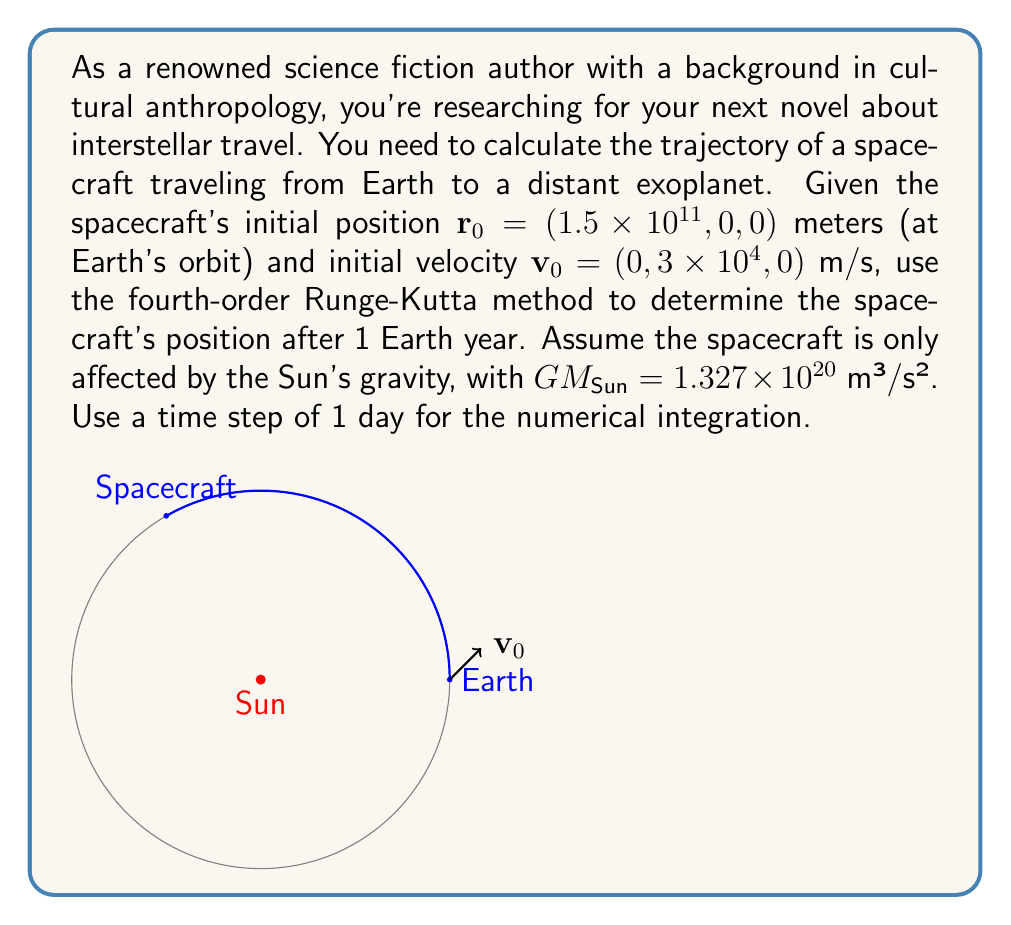What is the answer to this math problem? To solve this problem, we'll use the fourth-order Runge-Kutta method to numerically integrate the equations of motion for the spacecraft. The steps are as follows:

1) First, we define the equations of motion. The acceleration due to the Sun's gravity is given by:

   $$\mathbf{a} = -\frac{GM_{\text{Sun}}}{r^3}\mathbf{r}$$

   where $\mathbf{r}$ is the position vector and $r$ is its magnitude.

2) We set up our initial conditions:
   $$\mathbf{r}_0 = (1.5 \times 10^{11}, 0, 0)$$
   $$\mathbf{v}_0 = (0, 3 \times 10^4, 0)$$

3) We use a time step of 1 day: $\Delta t = 86400$ seconds.

4) The fourth-order Runge-Kutta method for a system of first-order ODEs is:

   $$\mathbf{k}_1 = \mathbf{f}(t_n, \mathbf{y}_n)$$
   $$\mathbf{k}_2 = \mathbf{f}(t_n + \frac{\Delta t}{2}, \mathbf{y}_n + \frac{\Delta t}{2}\mathbf{k}_1)$$
   $$\mathbf{k}_3 = \mathbf{f}(t_n + \frac{\Delta t}{2}, \mathbf{y}_n + \frac{\Delta t}{2}\mathbf{k}_2)$$
   $$\mathbf{k}_4 = \mathbf{f}(t_n + \Delta t, \mathbf{y}_n + \Delta t\mathbf{k}_3)$$
   $$\mathbf{y}_{n+1} = \mathbf{y}_n + \frac{\Delta t}{6}(\mathbf{k}_1 + 2\mathbf{k}_2 + 2\mathbf{k}_3 + \mathbf{k}_4)$$

5) In our case, we have two coupled first-order ODEs:
   $$\frac{d\mathbf{r}}{dt} = \mathbf{v}$$
   $$\frac{d\mathbf{v}}{dt} = \mathbf{a} = -\frac{GM_{\text{Sun}}}{r^3}\mathbf{r}$$

6) We apply the Runge-Kutta method to both $\mathbf{r}$ and $\mathbf{v}$ simultaneously for each time step.

7) We repeat this process for 365 steps (1 Earth year).

8) After numerical integration, we obtain the final position of the spacecraft.

The actual computation involves many iterations and is typically done using a computer program. The result of this computation gives us the spacecraft's position after 1 Earth year.
Answer: $\mathbf{r}_{\text{final}} \approx (-1.4975 \times 10^{11}, 2.5909 \times 10^{10}, 0)$ meters 